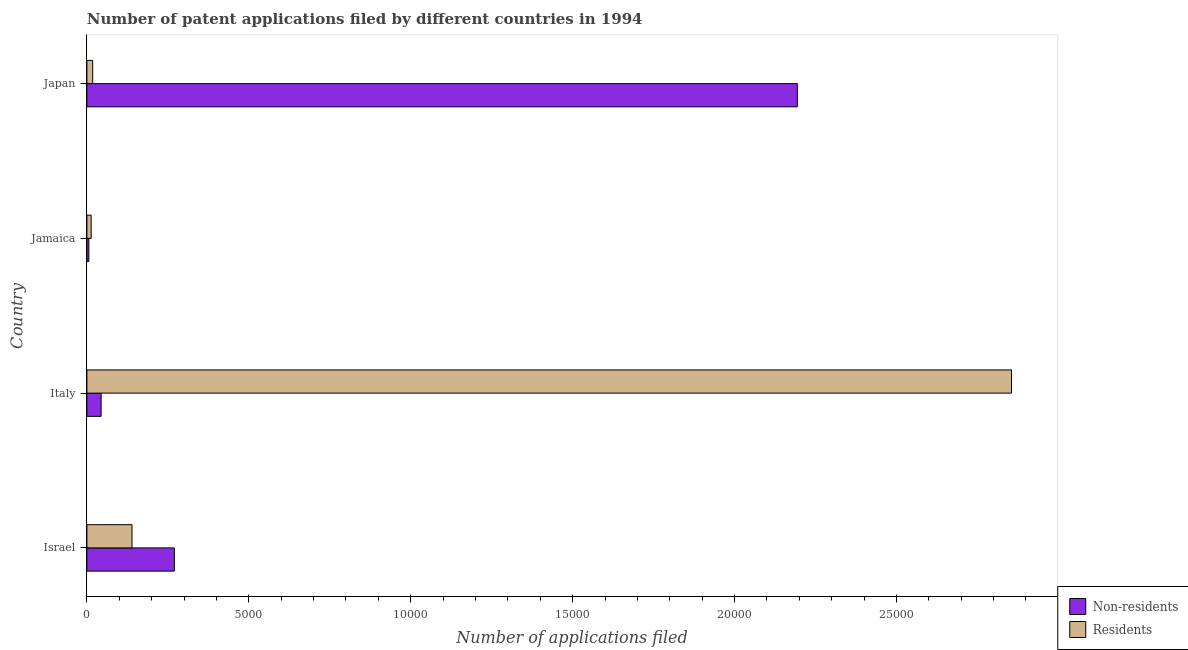How many groups of bars are there?
Provide a short and direct response. 4. Are the number of bars per tick equal to the number of legend labels?
Give a very brief answer. Yes. How many bars are there on the 1st tick from the top?
Make the answer very short. 2. In how many cases, is the number of bars for a given country not equal to the number of legend labels?
Keep it short and to the point. 0. What is the number of patent applications by non residents in Italy?
Give a very brief answer. 439. Across all countries, what is the maximum number of patent applications by residents?
Make the answer very short. 2.86e+04. Across all countries, what is the minimum number of patent applications by non residents?
Make the answer very short. 60. In which country was the number of patent applications by residents maximum?
Give a very brief answer. Italy. In which country was the number of patent applications by residents minimum?
Make the answer very short. Jamaica. What is the total number of patent applications by non residents in the graph?
Ensure brevity in your answer.  2.51e+04. What is the difference between the number of patent applications by non residents in Israel and that in Italy?
Keep it short and to the point. 2262. What is the difference between the number of patent applications by residents in Israel and the number of patent applications by non residents in Jamaica?
Provide a succinct answer. 1333. What is the average number of patent applications by residents per country?
Your answer should be very brief. 7564.5. What is the difference between the number of patent applications by residents and number of patent applications by non residents in Italy?
Your answer should be compact. 2.81e+04. In how many countries, is the number of patent applications by non residents greater than 28000 ?
Ensure brevity in your answer.  0. What is the ratio of the number of patent applications by residents in Italy to that in Japan?
Offer a terse response. 159.52. What is the difference between the highest and the second highest number of patent applications by residents?
Your answer should be very brief. 2.72e+04. What is the difference between the highest and the lowest number of patent applications by non residents?
Your answer should be compact. 2.19e+04. In how many countries, is the number of patent applications by non residents greater than the average number of patent applications by non residents taken over all countries?
Your answer should be very brief. 1. Is the sum of the number of patent applications by residents in Israel and Jamaica greater than the maximum number of patent applications by non residents across all countries?
Offer a terse response. No. What does the 2nd bar from the top in Israel represents?
Provide a succinct answer. Non-residents. What does the 1st bar from the bottom in Israel represents?
Provide a short and direct response. Non-residents. Are all the bars in the graph horizontal?
Provide a succinct answer. Yes. What is the difference between two consecutive major ticks on the X-axis?
Give a very brief answer. 5000. Are the values on the major ticks of X-axis written in scientific E-notation?
Give a very brief answer. No. Does the graph contain any zero values?
Give a very brief answer. No. What is the title of the graph?
Provide a short and direct response. Number of patent applications filed by different countries in 1994. Does "Male labourers" appear as one of the legend labels in the graph?
Offer a terse response. No. What is the label or title of the X-axis?
Offer a terse response. Number of applications filed. What is the label or title of the Y-axis?
Provide a succinct answer. Country. What is the Number of applications filed of Non-residents in Israel?
Ensure brevity in your answer.  2701. What is the Number of applications filed in Residents in Israel?
Your answer should be very brief. 1393. What is the Number of applications filed of Non-residents in Italy?
Your answer should be very brief. 439. What is the Number of applications filed in Residents in Italy?
Provide a short and direct response. 2.86e+04. What is the Number of applications filed in Residents in Jamaica?
Your response must be concise. 132. What is the Number of applications filed of Non-residents in Japan?
Your response must be concise. 2.19e+04. What is the Number of applications filed of Residents in Japan?
Your response must be concise. 179. Across all countries, what is the maximum Number of applications filed in Non-residents?
Your response must be concise. 2.19e+04. Across all countries, what is the maximum Number of applications filed in Residents?
Your answer should be very brief. 2.86e+04. Across all countries, what is the minimum Number of applications filed in Non-residents?
Offer a very short reply. 60. Across all countries, what is the minimum Number of applications filed in Residents?
Provide a succinct answer. 132. What is the total Number of applications filed in Non-residents in the graph?
Ensure brevity in your answer.  2.51e+04. What is the total Number of applications filed of Residents in the graph?
Provide a succinct answer. 3.03e+04. What is the difference between the Number of applications filed in Non-residents in Israel and that in Italy?
Give a very brief answer. 2262. What is the difference between the Number of applications filed of Residents in Israel and that in Italy?
Give a very brief answer. -2.72e+04. What is the difference between the Number of applications filed of Non-residents in Israel and that in Jamaica?
Your response must be concise. 2641. What is the difference between the Number of applications filed of Residents in Israel and that in Jamaica?
Your answer should be very brief. 1261. What is the difference between the Number of applications filed in Non-residents in Israel and that in Japan?
Keep it short and to the point. -1.92e+04. What is the difference between the Number of applications filed of Residents in Israel and that in Japan?
Your answer should be compact. 1214. What is the difference between the Number of applications filed in Non-residents in Italy and that in Jamaica?
Your answer should be very brief. 379. What is the difference between the Number of applications filed of Residents in Italy and that in Jamaica?
Give a very brief answer. 2.84e+04. What is the difference between the Number of applications filed of Non-residents in Italy and that in Japan?
Your answer should be very brief. -2.15e+04. What is the difference between the Number of applications filed of Residents in Italy and that in Japan?
Your answer should be very brief. 2.84e+04. What is the difference between the Number of applications filed of Non-residents in Jamaica and that in Japan?
Make the answer very short. -2.19e+04. What is the difference between the Number of applications filed of Residents in Jamaica and that in Japan?
Provide a succinct answer. -47. What is the difference between the Number of applications filed of Non-residents in Israel and the Number of applications filed of Residents in Italy?
Your answer should be compact. -2.59e+04. What is the difference between the Number of applications filed in Non-residents in Israel and the Number of applications filed in Residents in Jamaica?
Offer a very short reply. 2569. What is the difference between the Number of applications filed of Non-residents in Israel and the Number of applications filed of Residents in Japan?
Offer a terse response. 2522. What is the difference between the Number of applications filed of Non-residents in Italy and the Number of applications filed of Residents in Jamaica?
Your answer should be compact. 307. What is the difference between the Number of applications filed in Non-residents in Italy and the Number of applications filed in Residents in Japan?
Give a very brief answer. 260. What is the difference between the Number of applications filed in Non-residents in Jamaica and the Number of applications filed in Residents in Japan?
Your answer should be very brief. -119. What is the average Number of applications filed of Non-residents per country?
Make the answer very short. 6285. What is the average Number of applications filed of Residents per country?
Ensure brevity in your answer.  7564.5. What is the difference between the Number of applications filed of Non-residents and Number of applications filed of Residents in Israel?
Provide a short and direct response. 1308. What is the difference between the Number of applications filed in Non-residents and Number of applications filed in Residents in Italy?
Offer a very short reply. -2.81e+04. What is the difference between the Number of applications filed of Non-residents and Number of applications filed of Residents in Jamaica?
Offer a terse response. -72. What is the difference between the Number of applications filed in Non-residents and Number of applications filed in Residents in Japan?
Your answer should be compact. 2.18e+04. What is the ratio of the Number of applications filed of Non-residents in Israel to that in Italy?
Provide a succinct answer. 6.15. What is the ratio of the Number of applications filed in Residents in Israel to that in Italy?
Your answer should be very brief. 0.05. What is the ratio of the Number of applications filed of Non-residents in Israel to that in Jamaica?
Provide a succinct answer. 45.02. What is the ratio of the Number of applications filed of Residents in Israel to that in Jamaica?
Ensure brevity in your answer.  10.55. What is the ratio of the Number of applications filed in Non-residents in Israel to that in Japan?
Make the answer very short. 0.12. What is the ratio of the Number of applications filed in Residents in Israel to that in Japan?
Offer a terse response. 7.78. What is the ratio of the Number of applications filed in Non-residents in Italy to that in Jamaica?
Make the answer very short. 7.32. What is the ratio of the Number of applications filed in Residents in Italy to that in Jamaica?
Ensure brevity in your answer.  216.32. What is the ratio of the Number of applications filed in Non-residents in Italy to that in Japan?
Give a very brief answer. 0.02. What is the ratio of the Number of applications filed of Residents in Italy to that in Japan?
Your answer should be very brief. 159.52. What is the ratio of the Number of applications filed of Non-residents in Jamaica to that in Japan?
Your answer should be very brief. 0. What is the ratio of the Number of applications filed in Residents in Jamaica to that in Japan?
Provide a succinct answer. 0.74. What is the difference between the highest and the second highest Number of applications filed of Non-residents?
Give a very brief answer. 1.92e+04. What is the difference between the highest and the second highest Number of applications filed of Residents?
Give a very brief answer. 2.72e+04. What is the difference between the highest and the lowest Number of applications filed of Non-residents?
Make the answer very short. 2.19e+04. What is the difference between the highest and the lowest Number of applications filed of Residents?
Your answer should be very brief. 2.84e+04. 